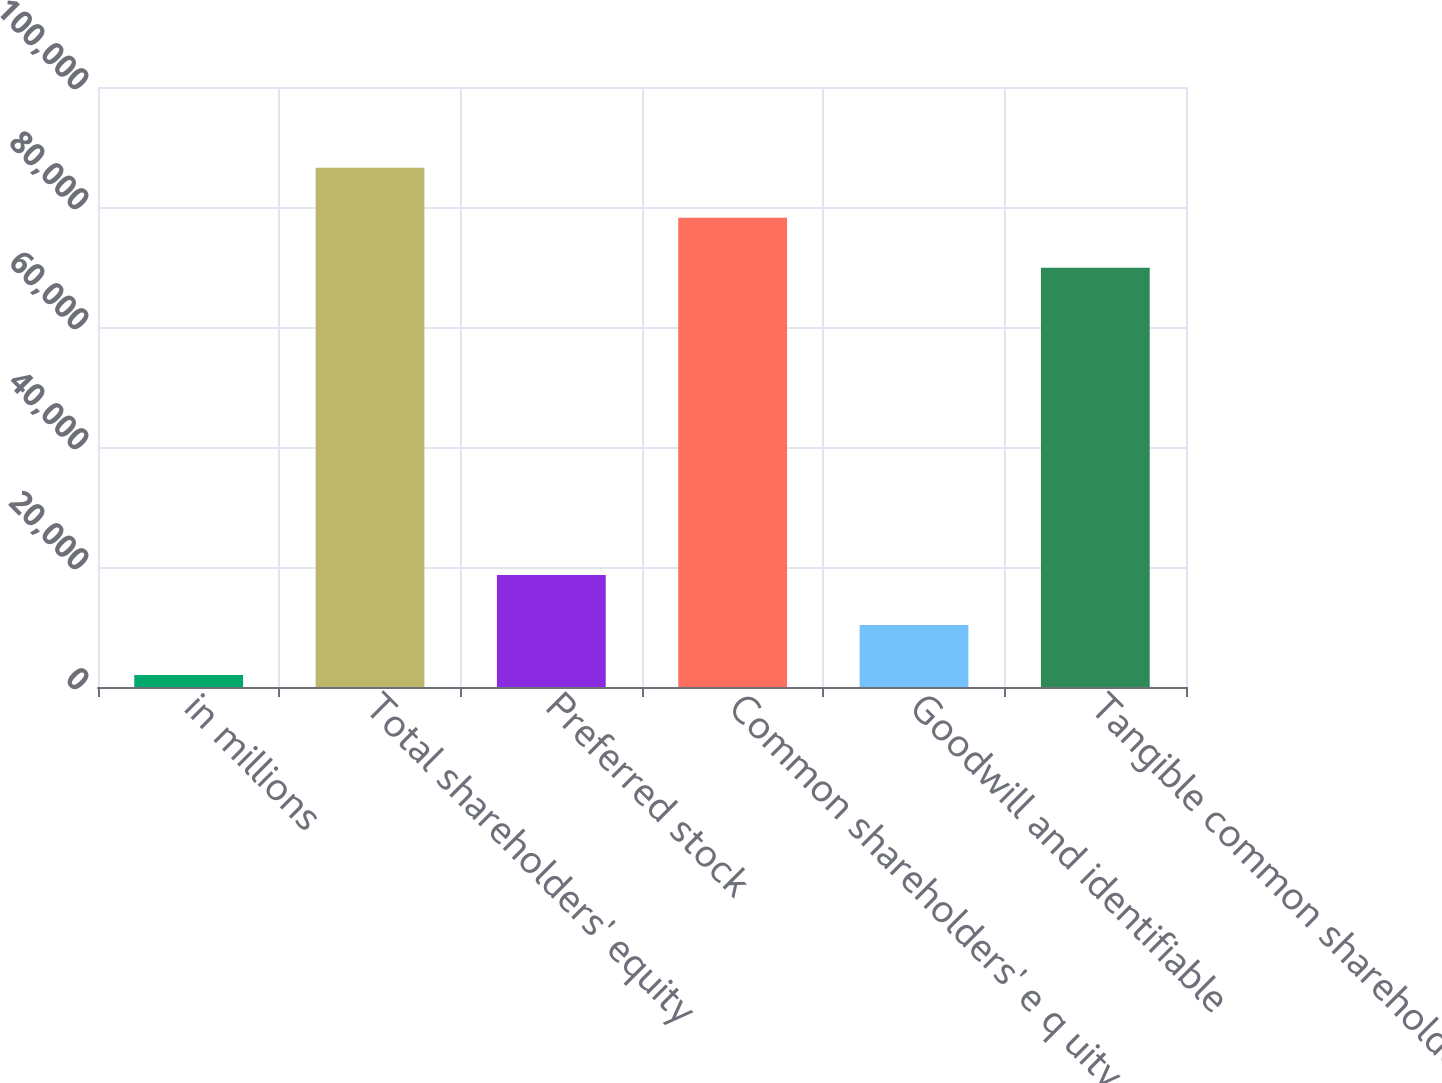Convert chart to OTSL. <chart><loc_0><loc_0><loc_500><loc_500><bar_chart><fcel>in millions<fcel>Total shareholders' equity<fcel>Preferred stock<fcel>Common shareholders' e q uity<fcel>Goodwill and identifiable<fcel>Tangible common shareholders'<nl><fcel>2018<fcel>86539<fcel>18662<fcel>78217<fcel>10340<fcel>69895<nl></chart> 